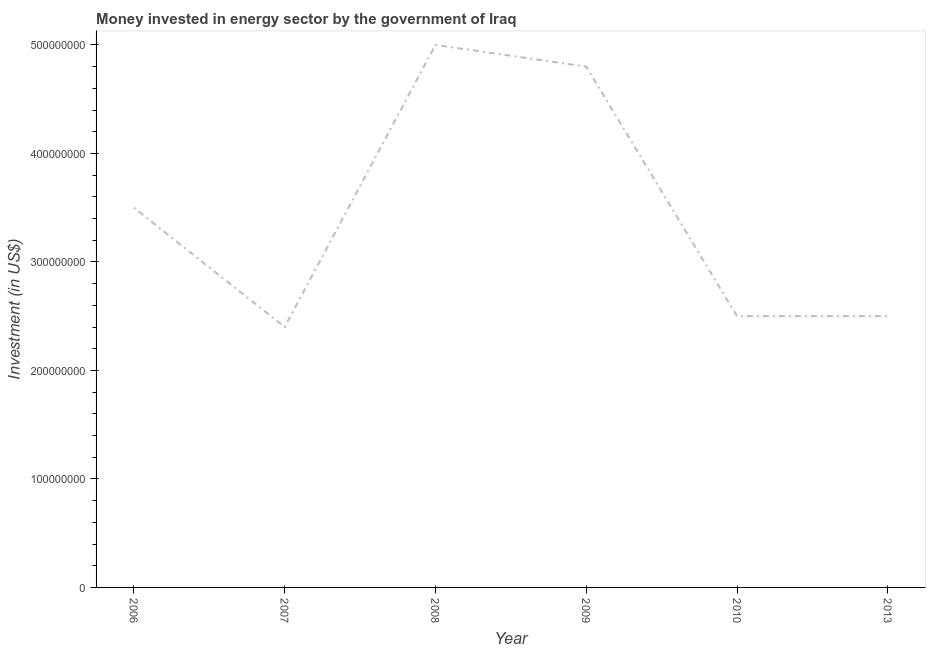What is the investment in energy in 2008?
Your answer should be compact. 5.00e+08. Across all years, what is the maximum investment in energy?
Give a very brief answer. 5.00e+08. Across all years, what is the minimum investment in energy?
Provide a succinct answer. 2.40e+08. What is the sum of the investment in energy?
Provide a short and direct response. 2.07e+09. What is the difference between the investment in energy in 2007 and 2010?
Your answer should be compact. -1.00e+07. What is the average investment in energy per year?
Provide a short and direct response. 3.45e+08. What is the median investment in energy?
Offer a terse response. 3.00e+08. In how many years, is the investment in energy greater than 40000000 US$?
Offer a terse response. 6. Do a majority of the years between 2009 and 2010 (inclusive) have investment in energy greater than 40000000 US$?
Your answer should be compact. Yes. What is the ratio of the investment in energy in 2009 to that in 2013?
Your response must be concise. 1.92. Is the investment in energy in 2008 less than that in 2013?
Provide a succinct answer. No. What is the difference between the highest and the second highest investment in energy?
Offer a terse response. 2.00e+07. What is the difference between the highest and the lowest investment in energy?
Provide a short and direct response. 2.60e+08. In how many years, is the investment in energy greater than the average investment in energy taken over all years?
Your response must be concise. 3. How many lines are there?
Your answer should be very brief. 1. How many years are there in the graph?
Provide a short and direct response. 6. Does the graph contain any zero values?
Provide a short and direct response. No. What is the title of the graph?
Ensure brevity in your answer.  Money invested in energy sector by the government of Iraq. What is the label or title of the Y-axis?
Provide a succinct answer. Investment (in US$). What is the Investment (in US$) of 2006?
Offer a terse response. 3.50e+08. What is the Investment (in US$) in 2007?
Make the answer very short. 2.40e+08. What is the Investment (in US$) of 2008?
Ensure brevity in your answer.  5.00e+08. What is the Investment (in US$) in 2009?
Provide a succinct answer. 4.80e+08. What is the Investment (in US$) of 2010?
Your response must be concise. 2.50e+08. What is the Investment (in US$) of 2013?
Offer a very short reply. 2.50e+08. What is the difference between the Investment (in US$) in 2006 and 2007?
Offer a terse response. 1.10e+08. What is the difference between the Investment (in US$) in 2006 and 2008?
Offer a very short reply. -1.50e+08. What is the difference between the Investment (in US$) in 2006 and 2009?
Your answer should be compact. -1.30e+08. What is the difference between the Investment (in US$) in 2006 and 2010?
Give a very brief answer. 1.00e+08. What is the difference between the Investment (in US$) in 2006 and 2013?
Make the answer very short. 1.00e+08. What is the difference between the Investment (in US$) in 2007 and 2008?
Your answer should be very brief. -2.60e+08. What is the difference between the Investment (in US$) in 2007 and 2009?
Make the answer very short. -2.40e+08. What is the difference between the Investment (in US$) in 2007 and 2010?
Make the answer very short. -1.00e+07. What is the difference between the Investment (in US$) in 2007 and 2013?
Make the answer very short. -1.00e+07. What is the difference between the Investment (in US$) in 2008 and 2009?
Ensure brevity in your answer.  2.00e+07. What is the difference between the Investment (in US$) in 2008 and 2010?
Offer a terse response. 2.50e+08. What is the difference between the Investment (in US$) in 2008 and 2013?
Offer a terse response. 2.50e+08. What is the difference between the Investment (in US$) in 2009 and 2010?
Your response must be concise. 2.30e+08. What is the difference between the Investment (in US$) in 2009 and 2013?
Provide a short and direct response. 2.30e+08. What is the ratio of the Investment (in US$) in 2006 to that in 2007?
Give a very brief answer. 1.46. What is the ratio of the Investment (in US$) in 2006 to that in 2009?
Offer a terse response. 0.73. What is the ratio of the Investment (in US$) in 2006 to that in 2010?
Provide a succinct answer. 1.4. What is the ratio of the Investment (in US$) in 2007 to that in 2008?
Give a very brief answer. 0.48. What is the ratio of the Investment (in US$) in 2007 to that in 2009?
Keep it short and to the point. 0.5. What is the ratio of the Investment (in US$) in 2007 to that in 2010?
Provide a short and direct response. 0.96. What is the ratio of the Investment (in US$) in 2008 to that in 2009?
Offer a very short reply. 1.04. What is the ratio of the Investment (in US$) in 2008 to that in 2010?
Provide a succinct answer. 2. What is the ratio of the Investment (in US$) in 2009 to that in 2010?
Ensure brevity in your answer.  1.92. What is the ratio of the Investment (in US$) in 2009 to that in 2013?
Offer a terse response. 1.92. 